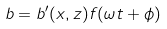<formula> <loc_0><loc_0><loc_500><loc_500>b = b ^ { \prime } ( x , z ) f ( \omega t + \phi )</formula> 